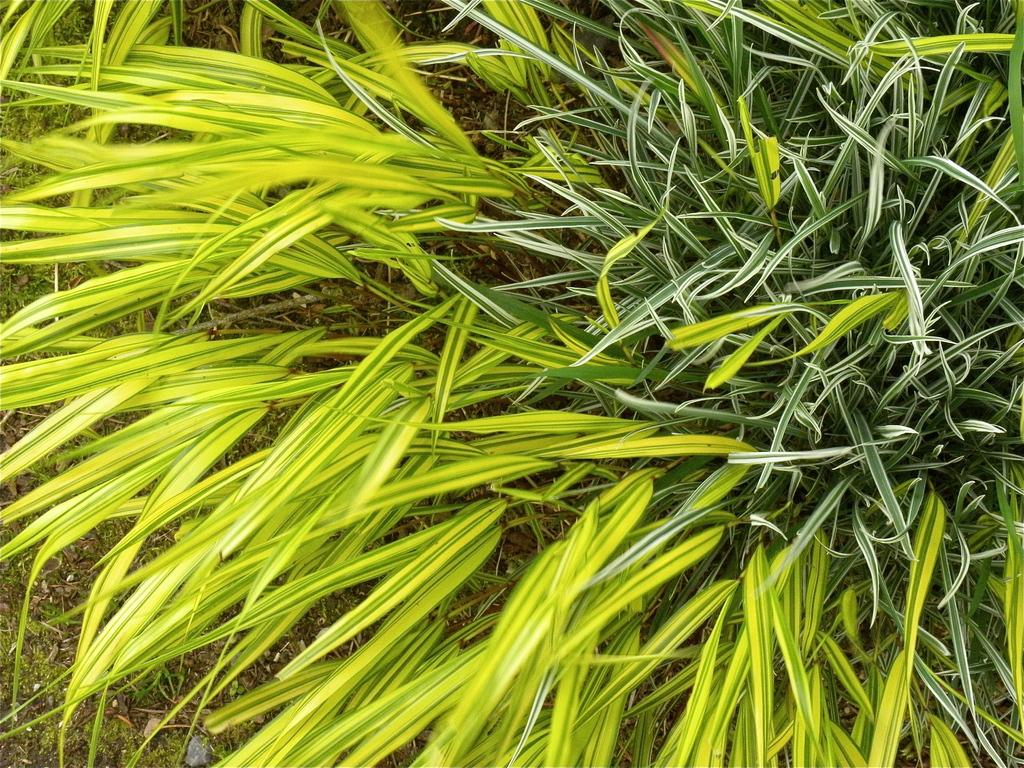What type of vegetation is present in the image? There are plants with leaves in the image. What can be seen in the background of the image? The ground is visible in the background of the image. What did the sister say to the plants before leaving in the image? There is no mention of a sister or any dialogue in the image, so it is not possible to answer that question. 